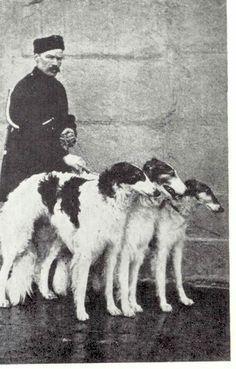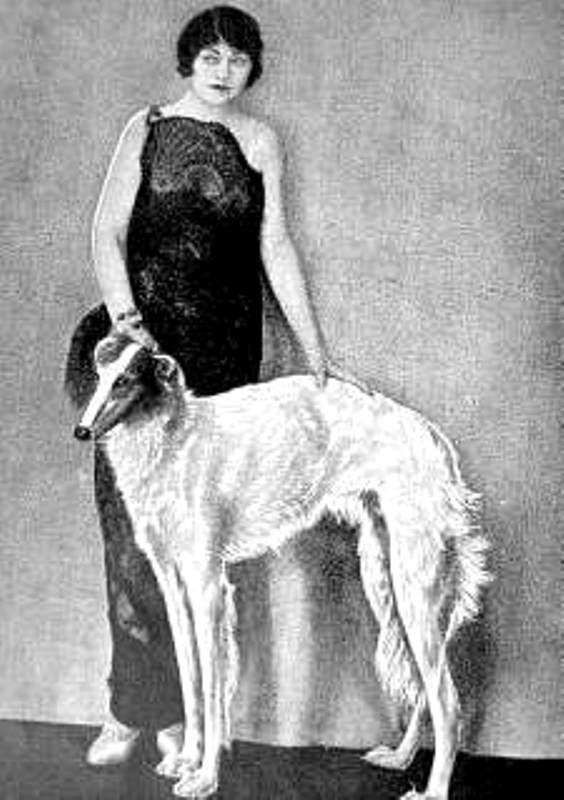The first image is the image on the left, the second image is the image on the right. Examine the images to the left and right. Is the description "There are only two dogs." accurate? Answer yes or no. No. 